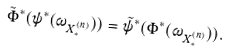<formula> <loc_0><loc_0><loc_500><loc_500>\tilde { \Phi } ^ { * } ( \psi ^ { * } ( \omega _ { X ^ { ( n ) } _ { * } } ) ) = \tilde { \psi } ^ { * } ( \Phi ^ { * } ( \omega _ { X ^ { ( n ) } _ { * } } ) ) .</formula> 